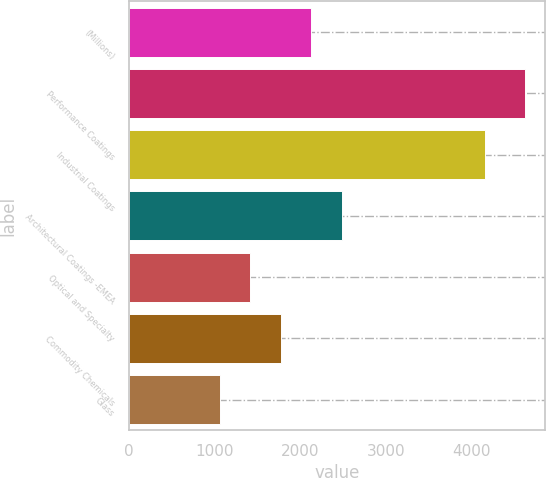Convert chart to OTSL. <chart><loc_0><loc_0><loc_500><loc_500><bar_chart><fcel>(Millions)<fcel>Performance Coatings<fcel>Industrial Coatings<fcel>Architectural Coatings -EMEA<fcel>Optical and Specialty<fcel>Commodity Chemicals<fcel>Glass<nl><fcel>2130.5<fcel>4626<fcel>4158<fcel>2487<fcel>1417.5<fcel>1774<fcel>1061<nl></chart> 